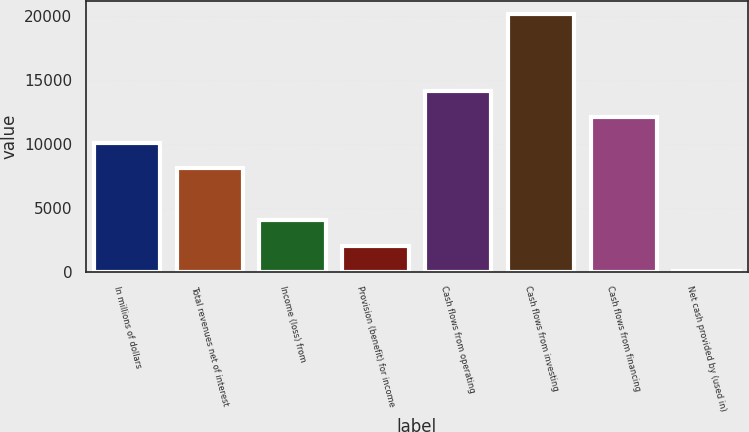Convert chart. <chart><loc_0><loc_0><loc_500><loc_500><bar_chart><fcel>In millions of dollars<fcel>Total revenues net of interest<fcel>Income (loss) from<fcel>Provision (benefit) for income<fcel>Cash flows from operating<fcel>Cash flows from investing<fcel>Cash flows from financing<fcel>Net cash provided by (used in)<nl><fcel>10065<fcel>8055<fcel>4035<fcel>2025<fcel>14085<fcel>20115<fcel>12075<fcel>15<nl></chart> 